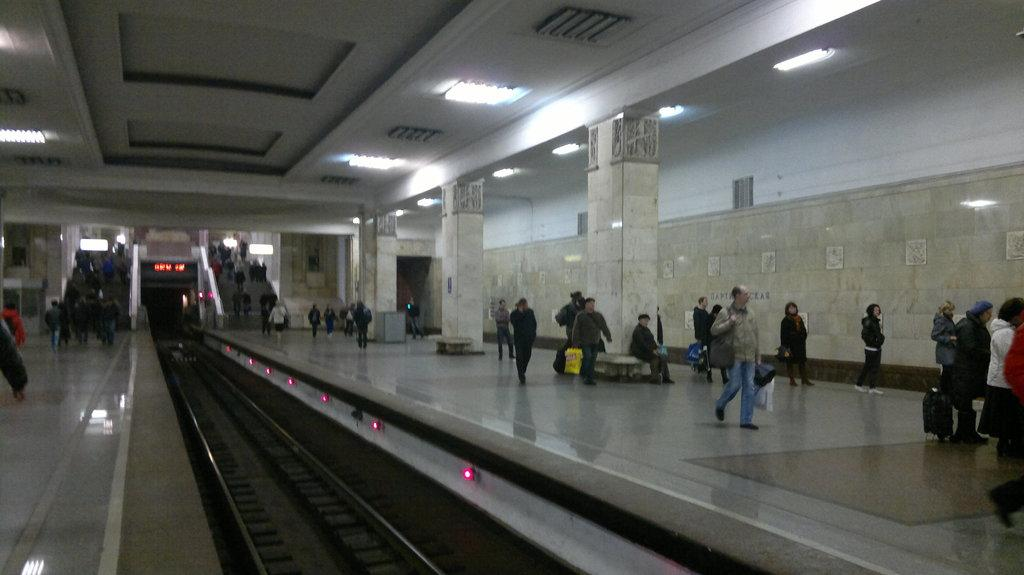What is located in the foreground of the image? There is a railway track in the foreground of the image. What are the people in the image doing? People are walking on either side of the platform. What architectural features can be seen in the image? There are pillars and a wall visible in the image. What is used for illumination in the image? Lights are present in the image. How can people access different levels in the image? There are stairs in the image. What type of bath can be seen in the image? There is no bath present in the image. 